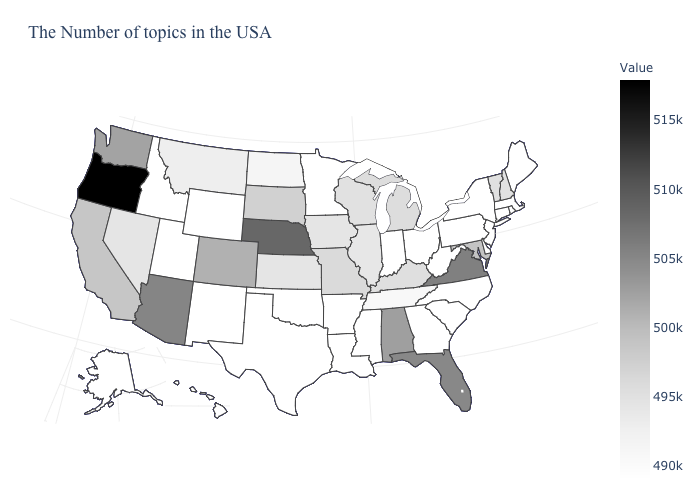Among the states that border Indiana , which have the lowest value?
Answer briefly. Ohio. Which states have the lowest value in the USA?
Keep it brief. Maine, Massachusetts, Rhode Island, Connecticut, New York, New Jersey, Delaware, Pennsylvania, North Carolina, South Carolina, West Virginia, Ohio, Georgia, Indiana, Mississippi, Louisiana, Arkansas, Minnesota, Oklahoma, Texas, Wyoming, New Mexico, Utah, Idaho, Alaska, Hawaii. Which states have the lowest value in the MidWest?
Be succinct. Ohio, Indiana, Minnesota. Among the states that border New Hampshire , does Maine have the highest value?
Write a very short answer. No. Does California have the highest value in the USA?
Give a very brief answer. No. Does the map have missing data?
Quick response, please. No. Among the states that border Colorado , does Nebraska have the lowest value?
Write a very short answer. No. 